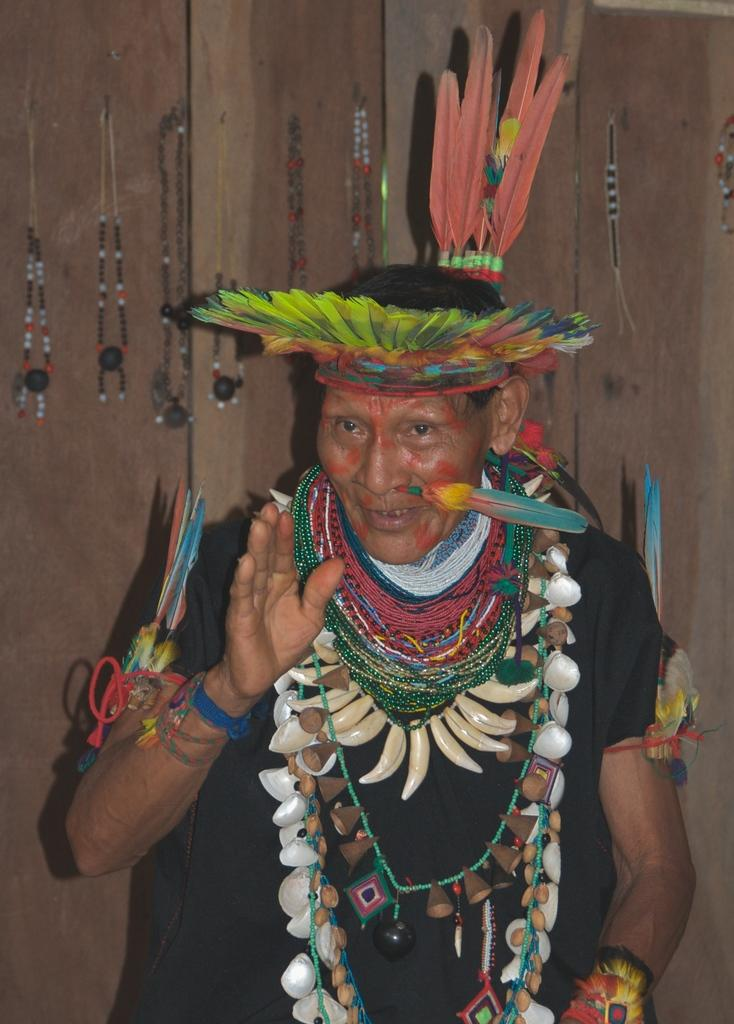What is the person in the image wearing? The person is wearing a costume in the image. What can be seen in the background of the image? There is a wall in the background of the image. Are there any additional features on the wall? Yes, there are chains on the wall in the image. What type of liquid is being poured from the locket in the image? There is no locket or liquid present in the image. How many sheep can be seen in the image? There are no sheep present in the image. 